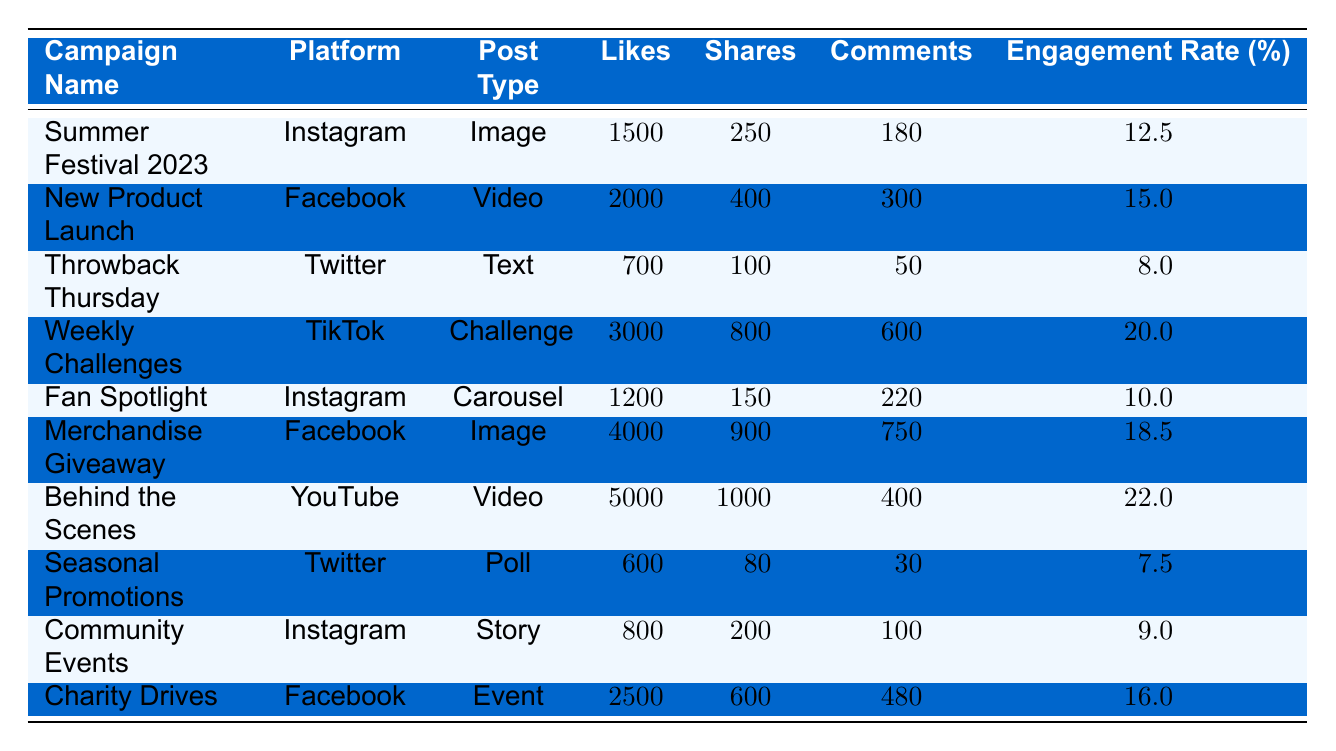What is the total number of likes across all campaigns? To calculate the total likes, we sum the likes from each campaign: 1500 + 2000 + 700 + 3000 + 1200 + 4000 + 5000 + 600 + 800 + 2500 = 21200
Answer: 21200 Which campaign had the highest engagement rate? By comparing the engagement rates, "Behind the Scenes" has the highest engagement rate at 22.0%.
Answer: Behind the Scenes Is the engagement rate for the "Fan Spotlight" campaign greater than or equal to 10%? The engagement rate for "Fan Spotlight" is 10.0%, which is equal to 10%. Therefore, it is true.
Answer: Yes What is the total number of shares for campaigns on Instagram? The campaigns on Instagram are "Summer Festival 2023" (250 shares), "Fan Spotlight" (150 shares), and "Community Events" (200 shares). Adding these gives: 250 + 150 + 200 = 600 shares.
Answer: 600 Does the "Merchandise Giveaway" campaign have more likes than the "Charity Drives" campaign? The "Merchandise Giveaway" has 4000 likes, while "Charity Drives" has 2500 likes. Since 4000 is greater than 2500, the statement is true.
Answer: Yes What is the average number of comments for campaigns on Facebook? The Facebook campaigns are "New Product Launch" (300 comments), "Merchandise Giveaway" (750 comments), and "Charity Drives" (480 comments). Summing these: 300 + 750 + 480 = 1530. There are 3 campaigns, so the average is 1530 / 3 = 510.
Answer: 510 Which post type received the most likes? The "Behind the Scenes" video received 5000 likes, which is the highest among all campaigns.
Answer: Video What is the difference in engagement rates between the "Weekly Challenges" and "Seasonal Promotions"? "Weekly Challenges" has an engagement rate of 20.0%, and "Seasonal Promotions" has 7.5%. The difference is 20.0 - 7.5 = 12.5.
Answer: 12.5 Which platform had the campaign with the fewest likes? The campaign "Throwback Thursday" on Twitter had the fewest likes at 700.
Answer: Twitter How many total comments were made on all the campaigns? By adding all comments together: 180 + 300 + 50 + 600 + 220 + 750 + 400 + 30 + 100 + 480 = 3160 comments.
Answer: 3160 